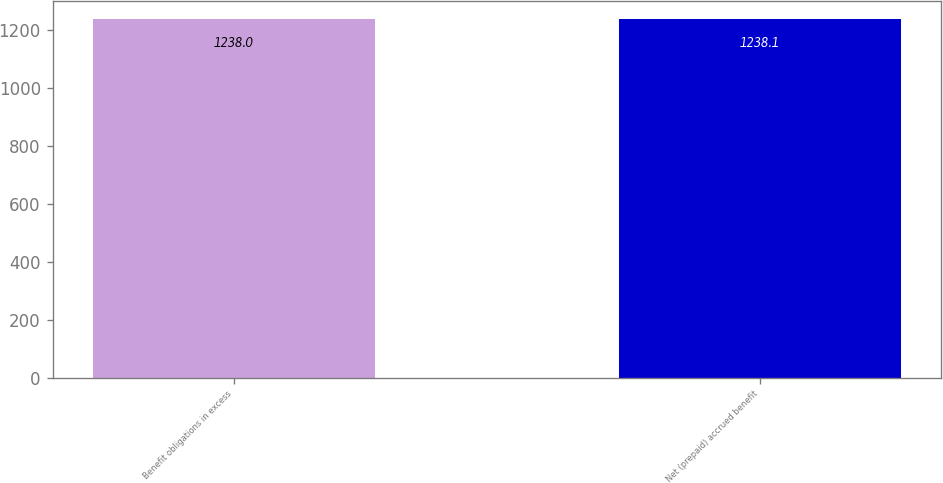Convert chart. <chart><loc_0><loc_0><loc_500><loc_500><bar_chart><fcel>Benefit obligations in excess<fcel>Net (prepaid) accrued benefit<nl><fcel>1238<fcel>1238.1<nl></chart> 